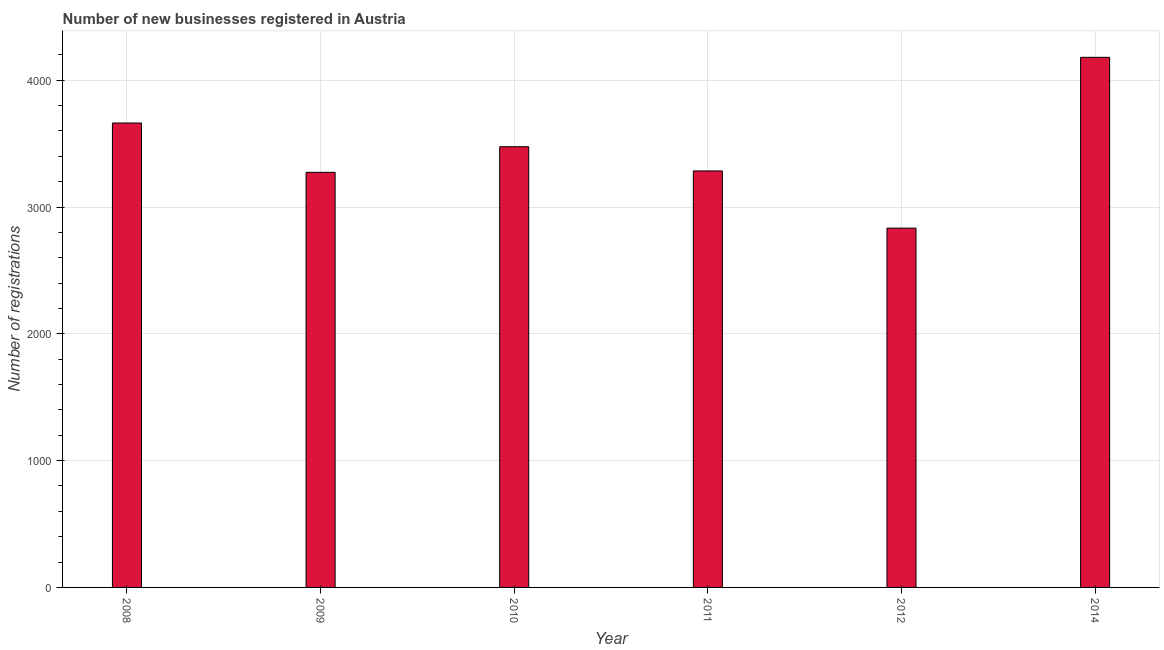Does the graph contain grids?
Offer a very short reply. Yes. What is the title of the graph?
Make the answer very short. Number of new businesses registered in Austria. What is the label or title of the X-axis?
Make the answer very short. Year. What is the label or title of the Y-axis?
Keep it short and to the point. Number of registrations. What is the number of new business registrations in 2014?
Offer a very short reply. 4181. Across all years, what is the maximum number of new business registrations?
Keep it short and to the point. 4181. Across all years, what is the minimum number of new business registrations?
Your response must be concise. 2834. In which year was the number of new business registrations maximum?
Offer a very short reply. 2014. What is the sum of the number of new business registrations?
Your answer should be very brief. 2.07e+04. What is the difference between the number of new business registrations in 2010 and 2011?
Your response must be concise. 191. What is the average number of new business registrations per year?
Provide a succinct answer. 3452. What is the median number of new business registrations?
Provide a short and direct response. 3380.5. Do a majority of the years between 2011 and 2010 (inclusive) have number of new business registrations greater than 1600 ?
Your response must be concise. No. What is the ratio of the number of new business registrations in 2010 to that in 2012?
Your answer should be compact. 1.23. Is the difference between the number of new business registrations in 2011 and 2012 greater than the difference between any two years?
Your answer should be compact. No. What is the difference between the highest and the second highest number of new business registrations?
Offer a terse response. 518. What is the difference between the highest and the lowest number of new business registrations?
Provide a succinct answer. 1347. Are all the bars in the graph horizontal?
Provide a succinct answer. No. What is the difference between two consecutive major ticks on the Y-axis?
Ensure brevity in your answer.  1000. Are the values on the major ticks of Y-axis written in scientific E-notation?
Keep it short and to the point. No. What is the Number of registrations in 2008?
Keep it short and to the point. 3663. What is the Number of registrations in 2009?
Your response must be concise. 3274. What is the Number of registrations of 2010?
Keep it short and to the point. 3476. What is the Number of registrations in 2011?
Your answer should be compact. 3285. What is the Number of registrations in 2012?
Your answer should be compact. 2834. What is the Number of registrations of 2014?
Offer a very short reply. 4181. What is the difference between the Number of registrations in 2008 and 2009?
Make the answer very short. 389. What is the difference between the Number of registrations in 2008 and 2010?
Provide a succinct answer. 187. What is the difference between the Number of registrations in 2008 and 2011?
Provide a short and direct response. 378. What is the difference between the Number of registrations in 2008 and 2012?
Give a very brief answer. 829. What is the difference between the Number of registrations in 2008 and 2014?
Your answer should be compact. -518. What is the difference between the Number of registrations in 2009 and 2010?
Ensure brevity in your answer.  -202. What is the difference between the Number of registrations in 2009 and 2012?
Ensure brevity in your answer.  440. What is the difference between the Number of registrations in 2009 and 2014?
Give a very brief answer. -907. What is the difference between the Number of registrations in 2010 and 2011?
Your answer should be compact. 191. What is the difference between the Number of registrations in 2010 and 2012?
Offer a very short reply. 642. What is the difference between the Number of registrations in 2010 and 2014?
Your answer should be compact. -705. What is the difference between the Number of registrations in 2011 and 2012?
Make the answer very short. 451. What is the difference between the Number of registrations in 2011 and 2014?
Your response must be concise. -896. What is the difference between the Number of registrations in 2012 and 2014?
Offer a very short reply. -1347. What is the ratio of the Number of registrations in 2008 to that in 2009?
Make the answer very short. 1.12. What is the ratio of the Number of registrations in 2008 to that in 2010?
Provide a succinct answer. 1.05. What is the ratio of the Number of registrations in 2008 to that in 2011?
Keep it short and to the point. 1.11. What is the ratio of the Number of registrations in 2008 to that in 2012?
Provide a short and direct response. 1.29. What is the ratio of the Number of registrations in 2008 to that in 2014?
Provide a short and direct response. 0.88. What is the ratio of the Number of registrations in 2009 to that in 2010?
Offer a terse response. 0.94. What is the ratio of the Number of registrations in 2009 to that in 2011?
Make the answer very short. 1. What is the ratio of the Number of registrations in 2009 to that in 2012?
Give a very brief answer. 1.16. What is the ratio of the Number of registrations in 2009 to that in 2014?
Your answer should be very brief. 0.78. What is the ratio of the Number of registrations in 2010 to that in 2011?
Give a very brief answer. 1.06. What is the ratio of the Number of registrations in 2010 to that in 2012?
Offer a terse response. 1.23. What is the ratio of the Number of registrations in 2010 to that in 2014?
Make the answer very short. 0.83. What is the ratio of the Number of registrations in 2011 to that in 2012?
Make the answer very short. 1.16. What is the ratio of the Number of registrations in 2011 to that in 2014?
Provide a short and direct response. 0.79. What is the ratio of the Number of registrations in 2012 to that in 2014?
Ensure brevity in your answer.  0.68. 